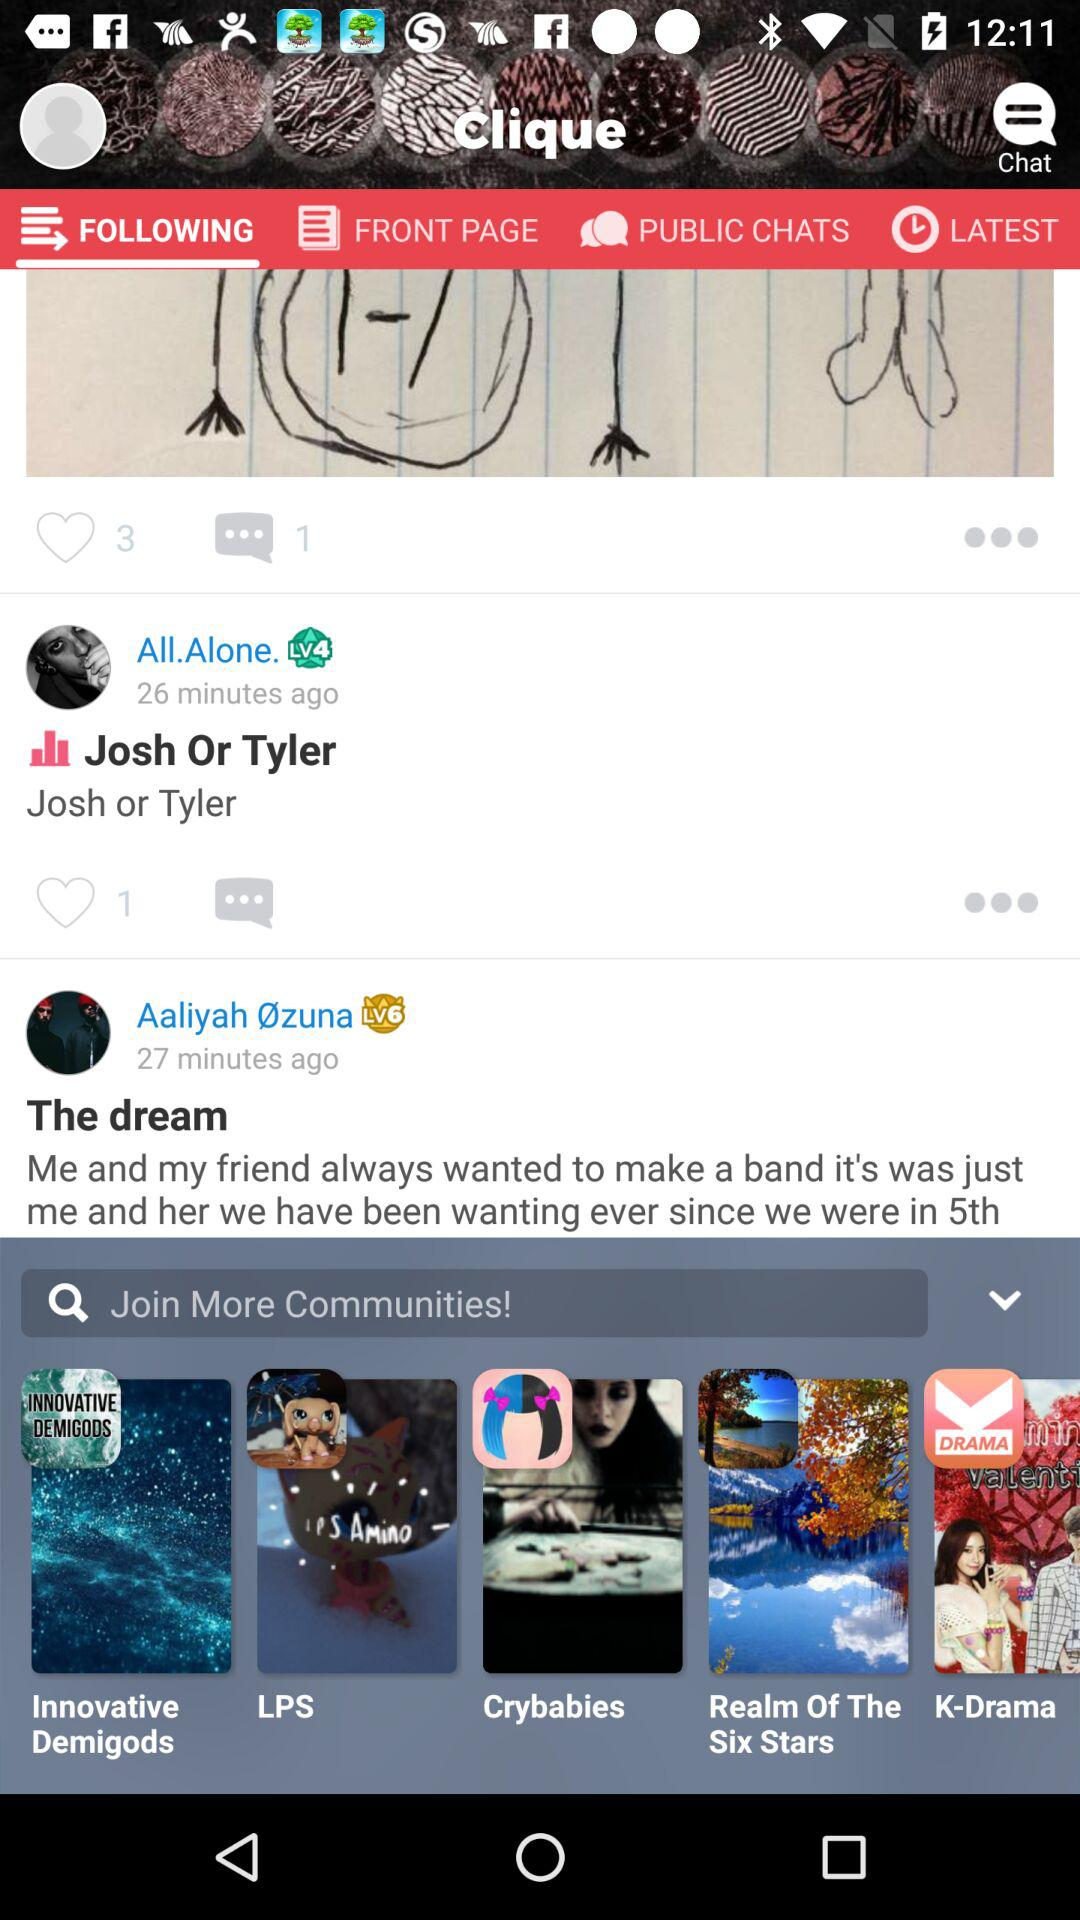When did "Aaliyah Øzuna" post? "Aaliyah Øzuna" posted 27 minutes ago. 